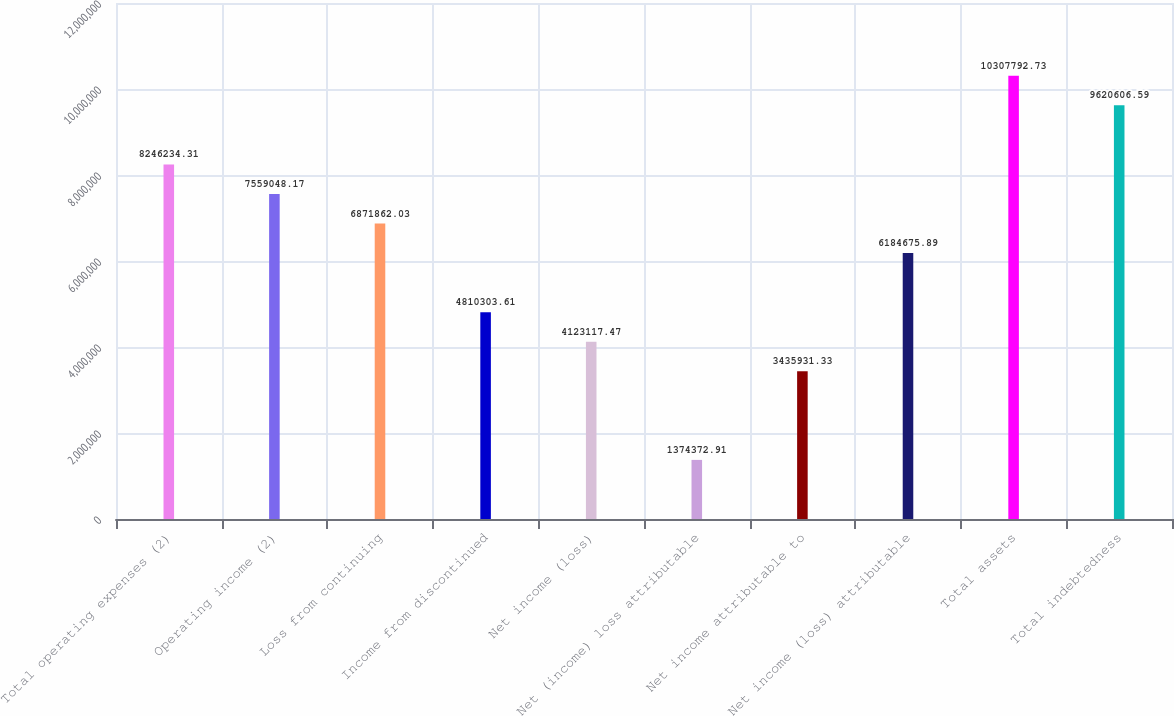Convert chart. <chart><loc_0><loc_0><loc_500><loc_500><bar_chart><fcel>Total operating expenses (2)<fcel>Operating income (2)<fcel>Loss from continuing<fcel>Income from discontinued<fcel>Net income (loss)<fcel>Net (income) loss attributable<fcel>Net income attributable to<fcel>Net income (loss) attributable<fcel>Total assets<fcel>Total indebtedness<nl><fcel>8.24623e+06<fcel>7.55905e+06<fcel>6.87186e+06<fcel>4.8103e+06<fcel>4.12312e+06<fcel>1.37437e+06<fcel>3.43593e+06<fcel>6.18468e+06<fcel>1.03078e+07<fcel>9.62061e+06<nl></chart> 